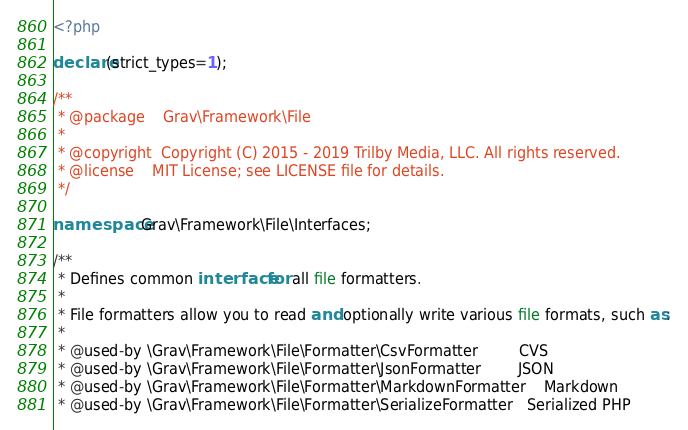<code> <loc_0><loc_0><loc_500><loc_500><_PHP_><?php

declare(strict_types=1);

/**
 * @package    Grav\Framework\File
 *
 * @copyright  Copyright (C) 2015 - 2019 Trilby Media, LLC. All rights reserved.
 * @license    MIT License; see LICENSE file for details.
 */

namespace Grav\Framework\File\Interfaces;

/**
 * Defines common interface for all file formatters.
 *
 * File formatters allow you to read and optionally write various file formats, such as:
 *
 * @used-by \Grav\Framework\File\Formatter\CsvFormatter         CVS
 * @used-by \Grav\Framework\File\Formatter\JsonFormatter        JSON
 * @used-by \Grav\Framework\File\Formatter\MarkdownFormatter    Markdown
 * @used-by \Grav\Framework\File\Formatter\SerializeFormatter   Serialized PHP</code> 